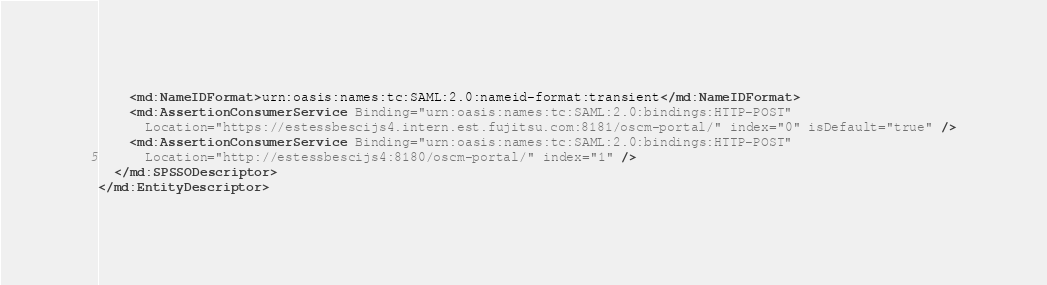Convert code to text. <code><loc_0><loc_0><loc_500><loc_500><_XML_>    <md:NameIDFormat>urn:oasis:names:tc:SAML:2.0:nameid-format:transient</md:NameIDFormat>
    <md:AssertionConsumerService Binding="urn:oasis:names:tc:SAML:2.0:bindings:HTTP-POST"
      Location="https://estessbescijs4.intern.est.fujitsu.com:8181/oscm-portal/" index="0" isDefault="true" />
    <md:AssertionConsumerService Binding="urn:oasis:names:tc:SAML:2.0:bindings:HTTP-POST"
      Location="http://estessbescijs4:8180/oscm-portal/" index="1" />
  </md:SPSSODescriptor>
</md:EntityDescriptor></code> 